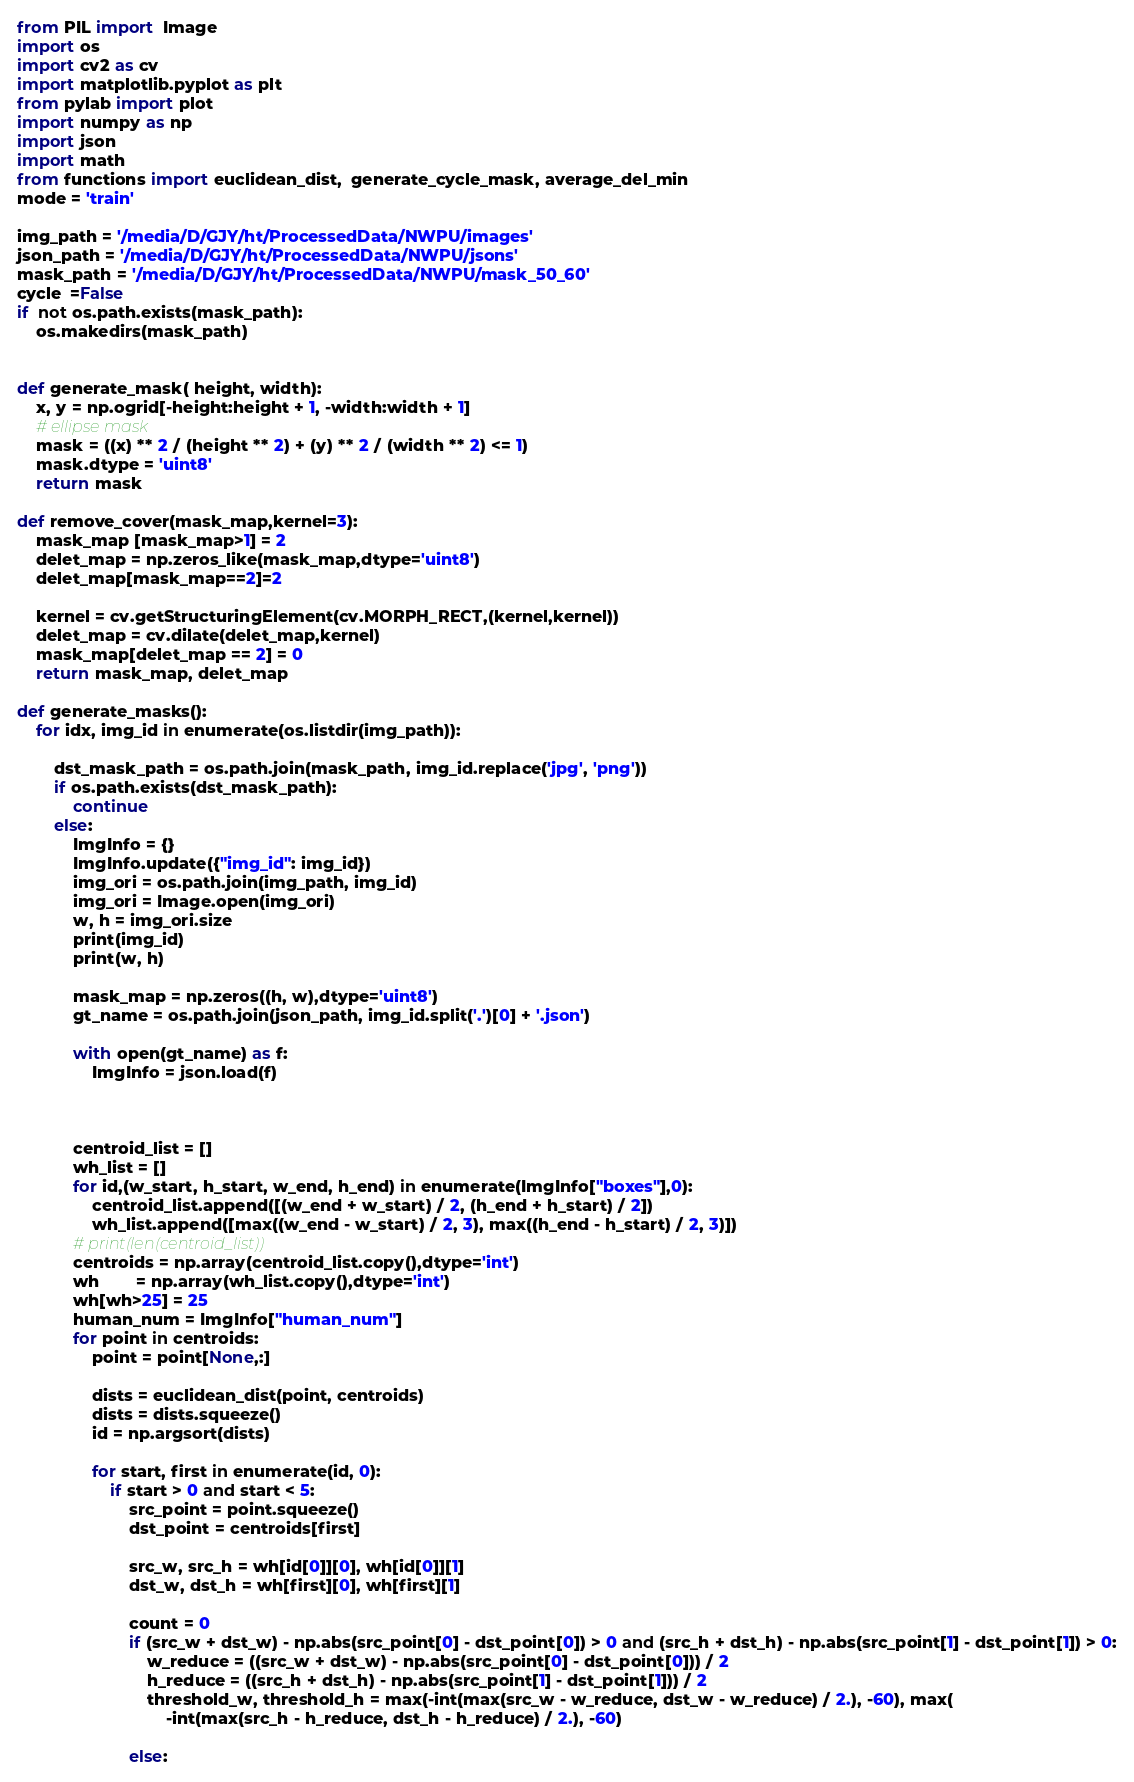<code> <loc_0><loc_0><loc_500><loc_500><_Python_>from PIL import  Image
import os
import cv2 as cv
import matplotlib.pyplot as plt
from pylab import plot
import numpy as np
import json
import math
from functions import euclidean_dist,  generate_cycle_mask, average_del_min
mode = 'train'

img_path = '/media/D/GJY/ht/ProcessedData/NWPU/images'
json_path = '/media/D/GJY/ht/ProcessedData/NWPU/jsons'
mask_path = '/media/D/GJY/ht/ProcessedData/NWPU/mask_50_60'
cycle  =False
if  not os.path.exists(mask_path):
    os.makedirs(mask_path)


def generate_mask( height, width):
    x, y = np.ogrid[-height:height + 1, -width:width + 1]
    # ellipse mask
    mask = ((x) ** 2 / (height ** 2) + (y) ** 2 / (width ** 2) <= 1)
    mask.dtype = 'uint8'
    return mask

def remove_cover(mask_map,kernel=3):
    mask_map [mask_map>1] = 2
    delet_map = np.zeros_like(mask_map,dtype='uint8')
    delet_map[mask_map==2]=2

    kernel = cv.getStructuringElement(cv.MORPH_RECT,(kernel,kernel))
    delet_map = cv.dilate(delet_map,kernel)
    mask_map[delet_map == 2] = 0
    return mask_map, delet_map

def generate_masks():
    for idx, img_id in enumerate(os.listdir(img_path)):

        dst_mask_path = os.path.join(mask_path, img_id.replace('jpg', 'png'))
        if os.path.exists(dst_mask_path):
            continue
        else:
            ImgInfo = {}
            ImgInfo.update({"img_id": img_id})
            img_ori = os.path.join(img_path, img_id)
            img_ori = Image.open(img_ori)
            w, h = img_ori.size
            print(img_id)
            print(w, h)

            mask_map = np.zeros((h, w),dtype='uint8')
            gt_name = os.path.join(json_path, img_id.split('.')[0] + '.json')

            with open(gt_name) as f:
                ImgInfo = json.load(f)



            centroid_list = []
            wh_list = []
            for id,(w_start, h_start, w_end, h_end) in enumerate(ImgInfo["boxes"],0):
                centroid_list.append([(w_end + w_start) / 2, (h_end + h_start) / 2])
                wh_list.append([max((w_end - w_start) / 2, 3), max((h_end - h_start) / 2, 3)])
            # print(len(centroid_list))
            centroids = np.array(centroid_list.copy(),dtype='int')
            wh        = np.array(wh_list.copy(),dtype='int')
            wh[wh>25] = 25
            human_num = ImgInfo["human_num"]
            for point in centroids:
                point = point[None,:]

                dists = euclidean_dist(point, centroids)
                dists = dists.squeeze()
                id = np.argsort(dists)

                for start, first in enumerate(id, 0):
                    if start > 0 and start < 5:
                        src_point = point.squeeze()
                        dst_point = centroids[first]

                        src_w, src_h = wh[id[0]][0], wh[id[0]][1]
                        dst_w, dst_h = wh[first][0], wh[first][1]

                        count = 0
                        if (src_w + dst_w) - np.abs(src_point[0] - dst_point[0]) > 0 and (src_h + dst_h) - np.abs(src_point[1] - dst_point[1]) > 0:
                            w_reduce = ((src_w + dst_w) - np.abs(src_point[0] - dst_point[0])) / 2
                            h_reduce = ((src_h + dst_h) - np.abs(src_point[1] - dst_point[1])) / 2
                            threshold_w, threshold_h = max(-int(max(src_w - w_reduce, dst_w - w_reduce) / 2.), -60), max(
                                -int(max(src_h - h_reduce, dst_h - h_reduce) / 2.), -60)

                        else:</code> 